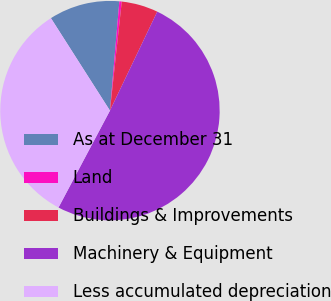<chart> <loc_0><loc_0><loc_500><loc_500><pie_chart><fcel>As at December 31<fcel>Land<fcel>Buildings & Improvements<fcel>Machinery & Equipment<fcel>Less accumulated depreciation<nl><fcel>10.41%<fcel>0.35%<fcel>5.38%<fcel>50.67%<fcel>33.19%<nl></chart> 